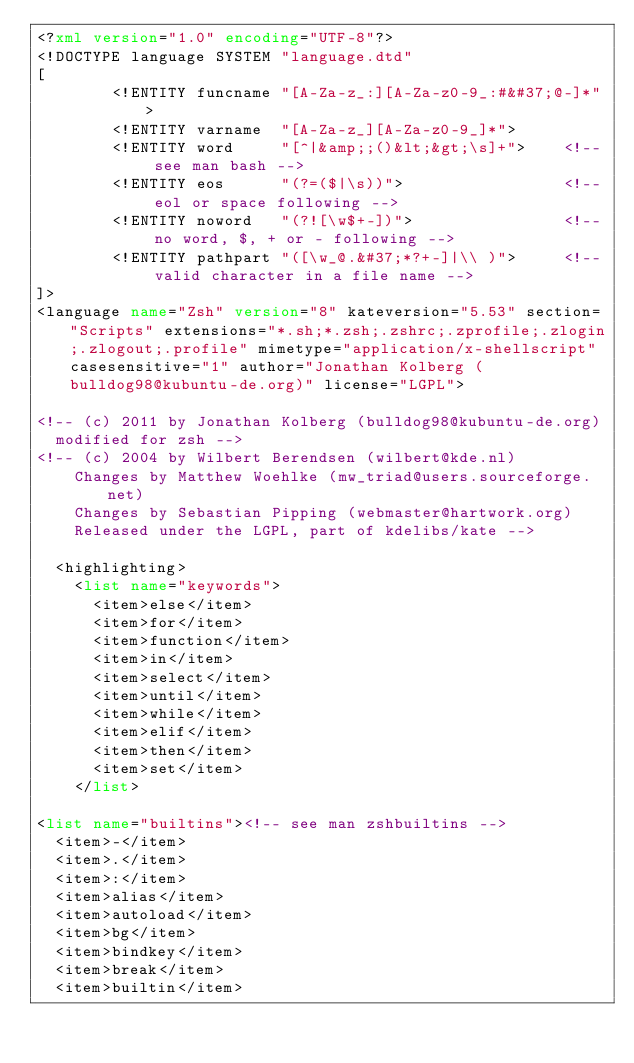<code> <loc_0><loc_0><loc_500><loc_500><_XML_><?xml version="1.0" encoding="UTF-8"?>
<!DOCTYPE language SYSTEM "language.dtd"
[
        <!ENTITY funcname "[A-Za-z_:][A-Za-z0-9_:#&#37;@-]*">
        <!ENTITY varname  "[A-Za-z_][A-Za-z0-9_]*">
        <!ENTITY word     "[^|&amp;;()&lt;&gt;\s]+">    <!-- see man bash -->
        <!ENTITY eos      "(?=($|\s))">                 <!-- eol or space following -->
        <!ENTITY noword   "(?![\w$+-])">                <!-- no word, $, + or - following -->
        <!ENTITY pathpart "([\w_@.&#37;*?+-]|\\ )">     <!-- valid character in a file name -->
]>
<language name="Zsh" version="8" kateversion="5.53" section="Scripts" extensions="*.sh;*.zsh;.zshrc;.zprofile;.zlogin;.zlogout;.profile" mimetype="application/x-shellscript" casesensitive="1" author="Jonathan Kolberg (bulldog98@kubuntu-de.org)" license="LGPL">

<!-- (c) 2011 by Jonathan Kolberg (bulldog98@kubuntu-de.org)
  modified for zsh -->
<!-- (c) 2004 by Wilbert Berendsen (wilbert@kde.nl)
    Changes by Matthew Woehlke (mw_triad@users.sourceforge.net)
    Changes by Sebastian Pipping (webmaster@hartwork.org)
    Released under the LGPL, part of kdelibs/kate -->

  <highlighting>
    <list name="keywords">
      <item>else</item>
      <item>for</item>
      <item>function</item>
      <item>in</item>
      <item>select</item>
      <item>until</item>
      <item>while</item>
      <item>elif</item>
      <item>then</item>
      <item>set</item>
    </list>

<list name="builtins"><!-- see man zshbuiltins -->
	<item>-</item>
	<item>.</item>
	<item>:</item>
	<item>alias</item>
	<item>autoload</item>
	<item>bg</item>
	<item>bindkey</item>
	<item>break</item>
	<item>builtin</item></code> 